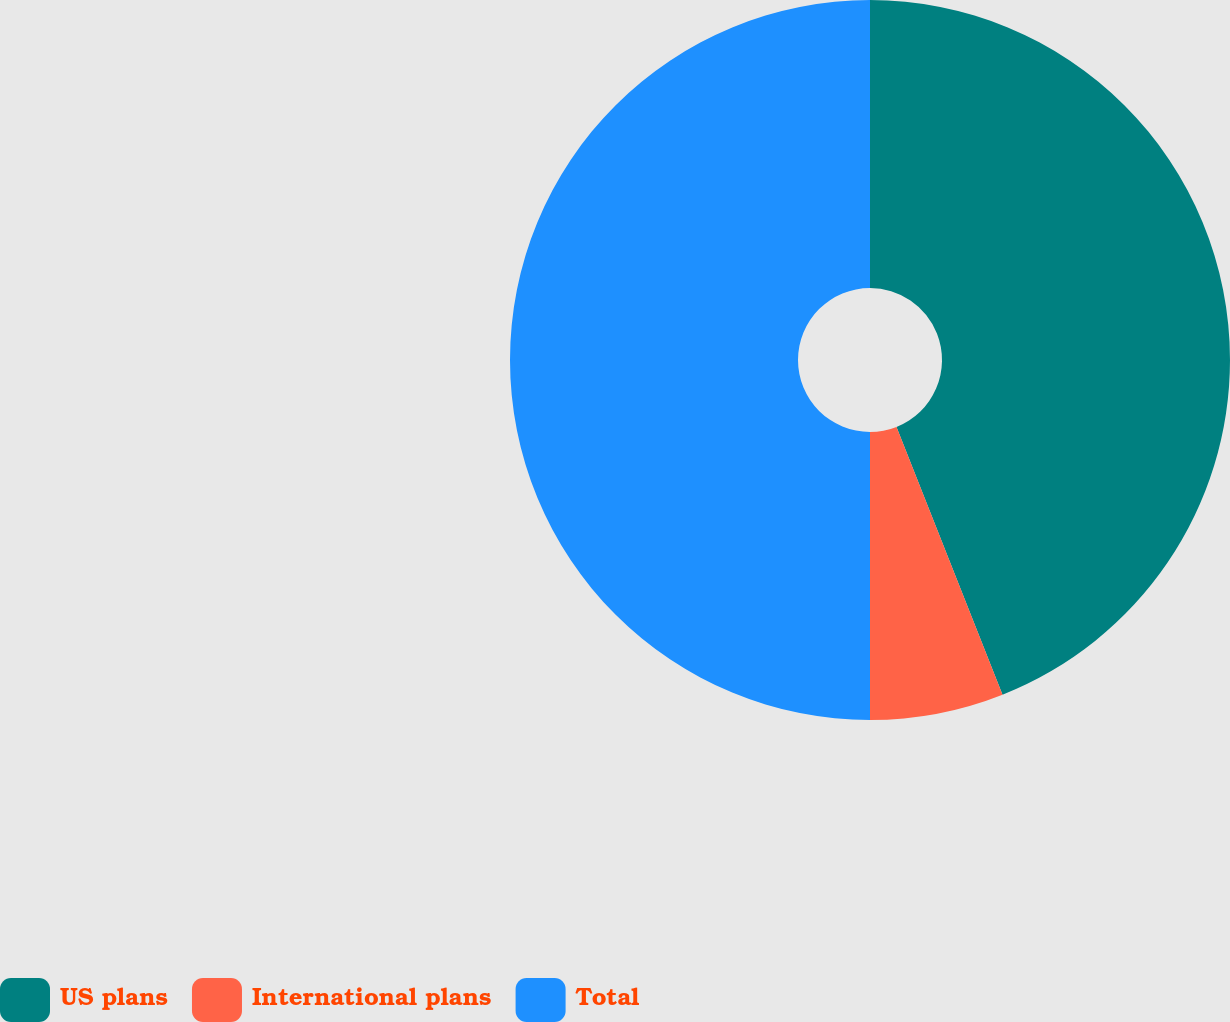Convert chart to OTSL. <chart><loc_0><loc_0><loc_500><loc_500><pie_chart><fcel>US plans<fcel>International plans<fcel>Total<nl><fcel>44.0%<fcel>6.0%<fcel>50.0%<nl></chart> 